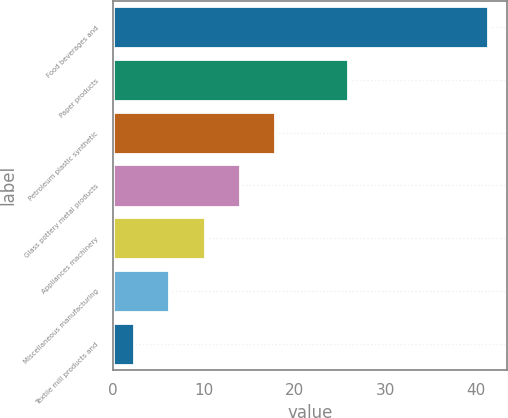<chart> <loc_0><loc_0><loc_500><loc_500><bar_chart><fcel>Food beverages and<fcel>Paper products<fcel>Petroleum plastic synthetic<fcel>Glass pottery metal products<fcel>Appliances machinery<fcel>Miscellaneous manufacturing<fcel>Textile mill products and<nl><fcel>41.3<fcel>25.9<fcel>17.9<fcel>14<fcel>10.1<fcel>6.2<fcel>2.3<nl></chart> 